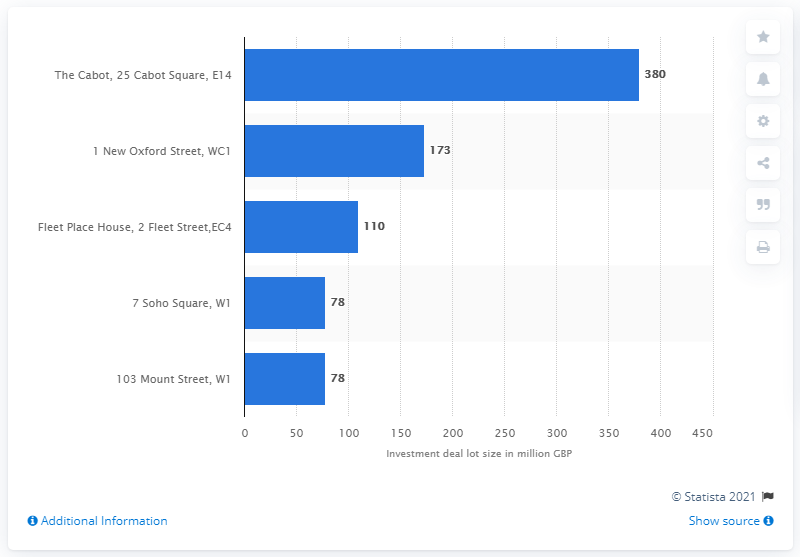Mention a couple of crucial points in this snapshot. LINK REIT paid 380... for a property located on The Cabot, 25 Cabot Square, E14. 